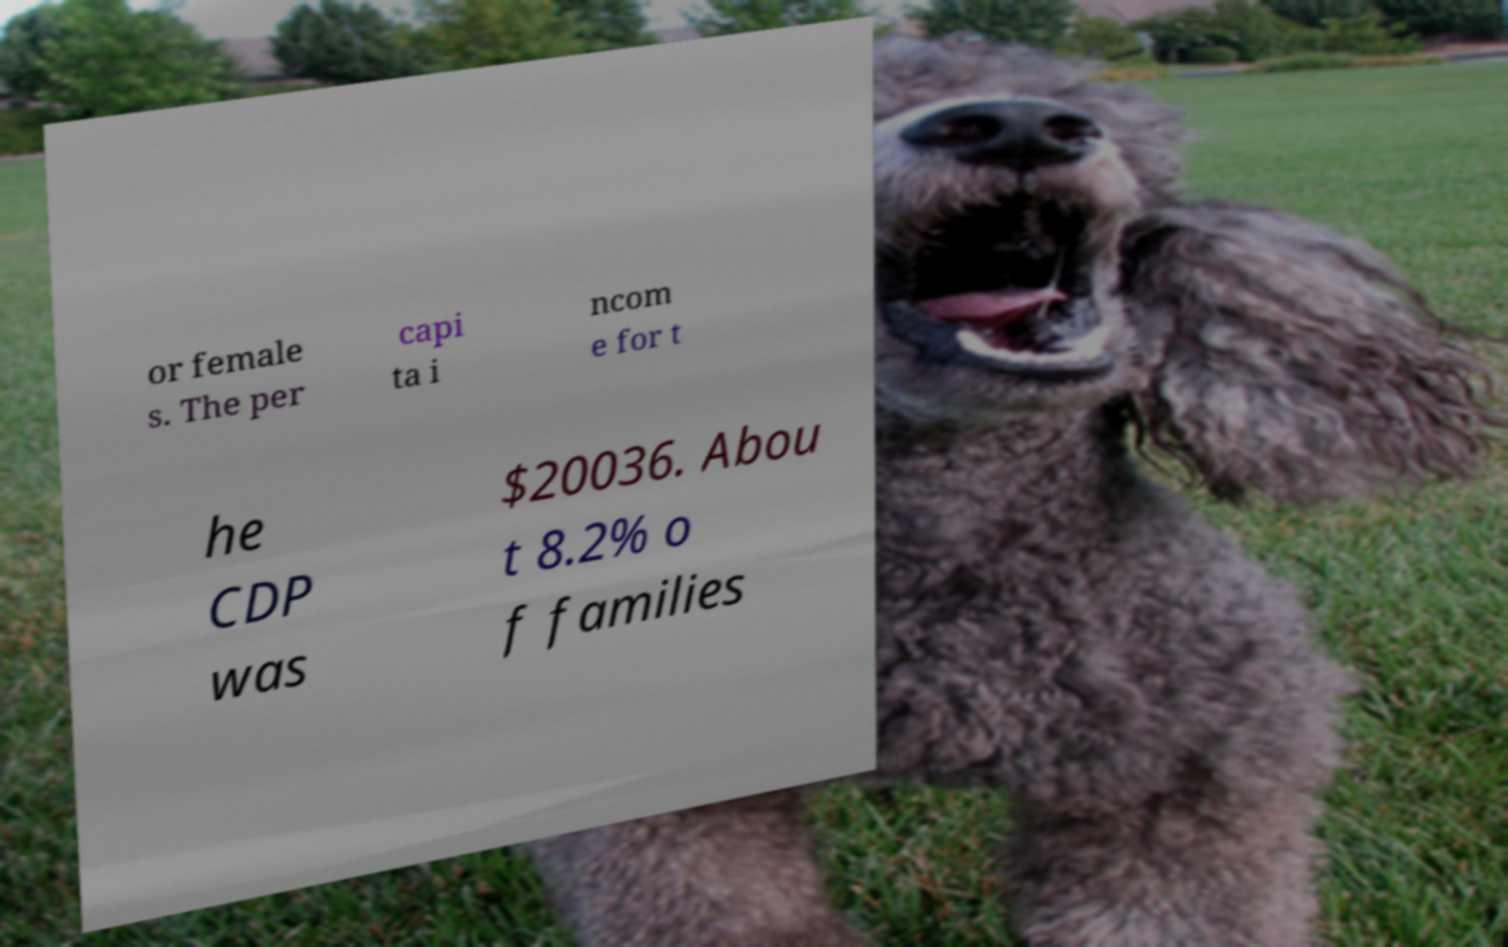There's text embedded in this image that I need extracted. Can you transcribe it verbatim? or female s. The per capi ta i ncom e for t he CDP was $20036. Abou t 8.2% o f families 